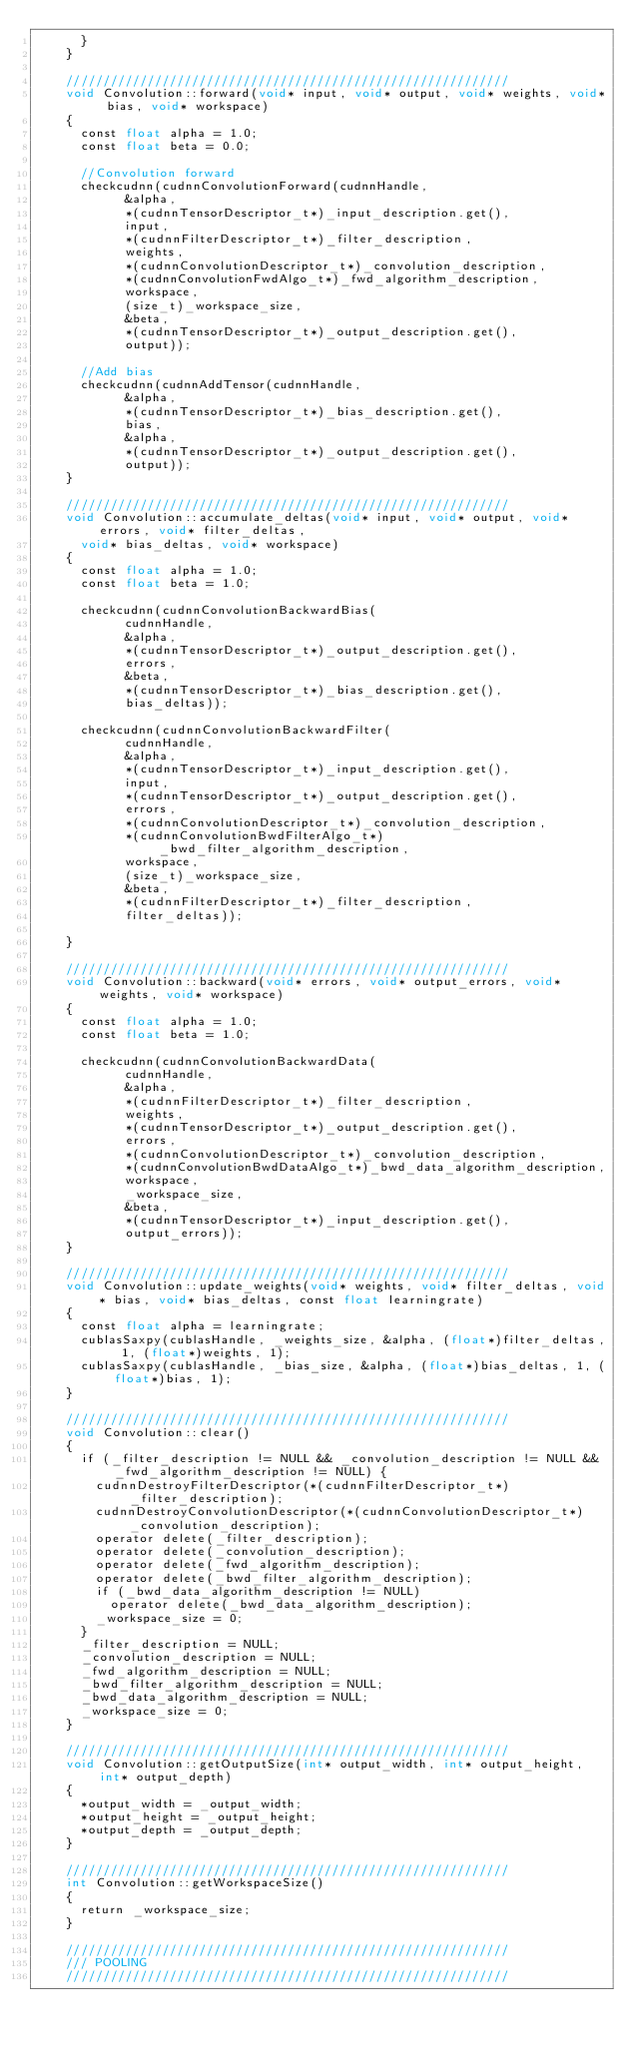Convert code to text. <code><loc_0><loc_0><loc_500><loc_500><_Cuda_>			}
		}
		
		////////////////////////////////////////////////////////////
		void Convolution::forward(void* input, void* output, void* weights, void* bias, void* workspace) 
		{
			const float alpha = 1.0;
			const float beta = 0.0;
			
			//Convolution forward
			checkcudnn(cudnnConvolutionForward(cudnnHandle,
						&alpha, 
						*(cudnnTensorDescriptor_t*)_input_description.get(),
						input, 
						*(cudnnFilterDescriptor_t*)_filter_description, 
						weights,
						*(cudnnConvolutionDescriptor_t*)_convolution_description, 
						*(cudnnConvolutionFwdAlgo_t*)_fwd_algorithm_description, 
						workspace, 
						(size_t)_workspace_size, 
						&beta,
						*(cudnnTensorDescriptor_t*)_output_description.get(), 
						output));
			
			//Add bias
			checkcudnn(cudnnAddTensor(cudnnHandle,
						&alpha,
						*(cudnnTensorDescriptor_t*)_bias_description.get(),
						bias,
						&alpha,
						*(cudnnTensorDescriptor_t*)_output_description.get(),
						output));
		}
		
		////////////////////////////////////////////////////////////
		void Convolution::accumulate_deltas(void* input, void* output, void* errors, void* filter_deltas,
			void* bias_deltas, void* workspace)
		{
			const float alpha = 1.0;
			const float beta = 1.0;
			
			checkcudnn(cudnnConvolutionBackwardBias(
						cudnnHandle,
						&alpha,
						*(cudnnTensorDescriptor_t*)_output_description.get(),
						errors,
						&beta,
						*(cudnnTensorDescriptor_t*)_bias_description.get(),
						bias_deltas));

			checkcudnn(cudnnConvolutionBackwardFilter(
						cudnnHandle,
						&alpha,
						*(cudnnTensorDescriptor_t*)_input_description.get(),
						input,
						*(cudnnTensorDescriptor_t*)_output_description.get(),
						errors,
						*(cudnnConvolutionDescriptor_t*)_convolution_description, 
						*(cudnnConvolutionBwdFilterAlgo_t*)_bwd_filter_algorithm_description,
						workspace,
						(size_t)_workspace_size,
						&beta,
						*(cudnnFilterDescriptor_t*)_filter_description,
						filter_deltas));
			
		}

		////////////////////////////////////////////////////////////
		void Convolution::backward(void* errors, void* output_errors, void* weights, void* workspace)
		{
			const float alpha = 1.0;
			const float beta = 1.0;

			checkcudnn(cudnnConvolutionBackwardData(
						cudnnHandle,
						&alpha,
						*(cudnnFilterDescriptor_t*)_filter_description,
						weights,
						*(cudnnTensorDescriptor_t*)_output_description.get(),
						errors,
						*(cudnnConvolutionDescriptor_t*)_convolution_description, 
						*(cudnnConvolutionBwdDataAlgo_t*)_bwd_data_algorithm_description,
						workspace,
						_workspace_size,
						&beta,
						*(cudnnTensorDescriptor_t*)_input_description.get(),
						output_errors));
		}
		
		////////////////////////////////////////////////////////////
		void Convolution::update_weights(void* weights, void* filter_deltas, void* bias, void* bias_deltas, const float learningrate)
		{
			const float alpha = learningrate;
			cublasSaxpy(cublasHandle, _weights_size, &alpha, (float*)filter_deltas, 1, (float*)weights, 1);
			cublasSaxpy(cublasHandle, _bias_size, &alpha, (float*)bias_deltas, 1, (float*)bias, 1);
		}

		////////////////////////////////////////////////////////////
		void Convolution::clear()
		{
			if (_filter_description != NULL && _convolution_description != NULL && _fwd_algorithm_description != NULL) {
				cudnnDestroyFilterDescriptor(*(cudnnFilterDescriptor_t*)_filter_description);
				cudnnDestroyConvolutionDescriptor(*(cudnnConvolutionDescriptor_t*)_convolution_description);
				operator delete(_filter_description);
				operator delete(_convolution_description);
				operator delete(_fwd_algorithm_description);
				operator delete(_bwd_filter_algorithm_description);
				if (_bwd_data_algorithm_description != NULL)
					operator delete(_bwd_data_algorithm_description);
				_workspace_size = 0;
			}
			_filter_description = NULL;
			_convolution_description = NULL;
			_fwd_algorithm_description = NULL;
			_bwd_filter_algorithm_description = NULL;
			_bwd_data_algorithm_description = NULL;
			_workspace_size = 0;
		}
		
		////////////////////////////////////////////////////////////
		void Convolution::getOutputSize(int* output_width, int* output_height, int* output_depth)
		{
			*output_width = _output_width;
			*output_height = _output_height;
			*output_depth = _output_depth;
		}
		
		////////////////////////////////////////////////////////////
		int Convolution::getWorkspaceSize()
		{
			return _workspace_size;
		}
		
		////////////////////////////////////////////////////////////
		///	POOLING
		////////////////////////////////////////////////////////////
		</code> 